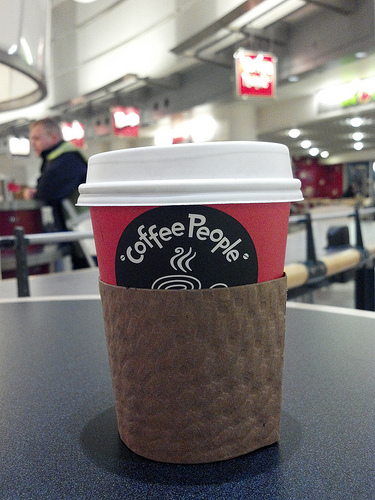<image>
Is the people next to the coffee? Yes. The people is positioned adjacent to the coffee, located nearby in the same general area. 